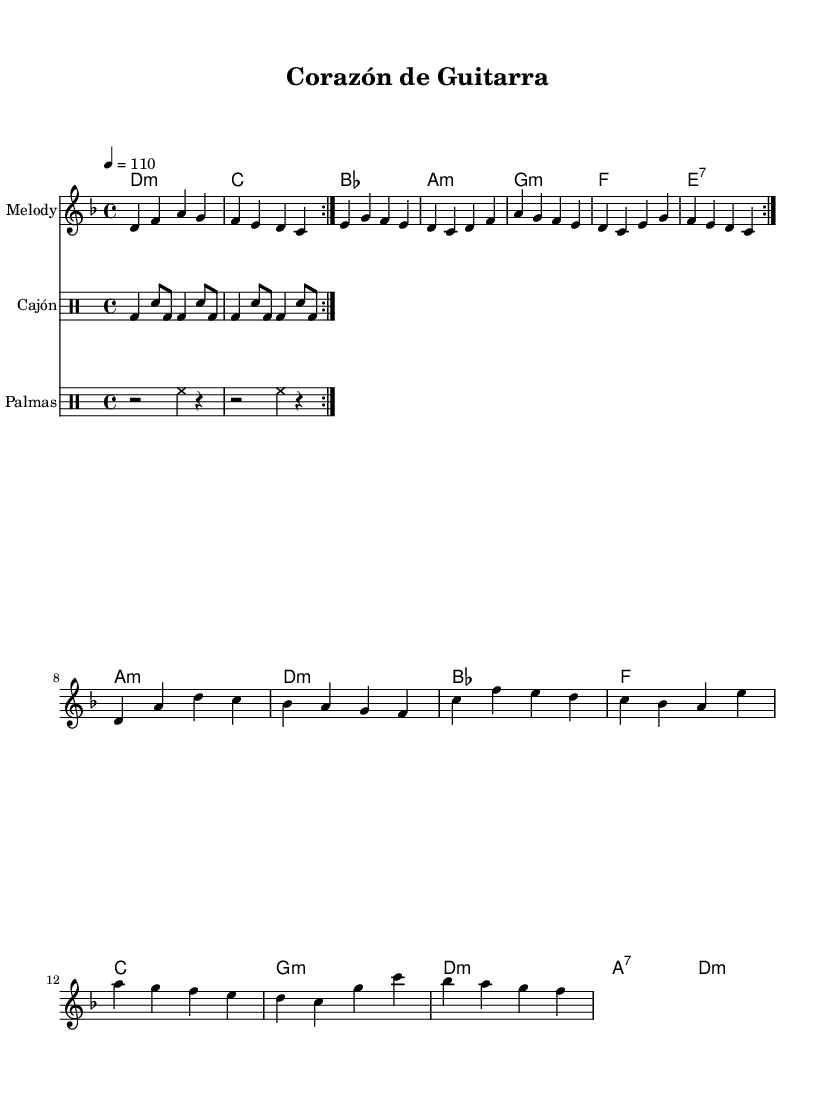What is the key signature of this music? The key is D minor, which has one flat (B flat). The key signature is indicated at the beginning of the staff.
Answer: D minor What is the time signature of this music? The time signature is indicated at the beginning of the piece, showing four beats per measure. It is represented as 4/4 at the beginning of the score.
Answer: 4/4 What is the tempo marking for this piece? The tempo is indicated at the beginning with "4 = 110," which represents a quarter note beat at a speed of 110 beats per minute.
Answer: 110 How many measures are in the melody section? By counting the measures in the melody line, we tally a total of 16 measures as indicated by the bar lines that separate each measure.
Answer: 16 What are the main instruments used in this piece? The score includes a melody staff, a cajón (drum), and palmas (hand clapping), specified in the instrument names at the start of each section.
Answer: Melody, Cajón, Palmas What is the first chord of the harmonies? The first chord indicated in the chord section is D minor, which is represented by the chord naming at the beginning of the harmonies.
Answer: D:m What is the rhythmic pattern of the cajón part? The cajón part consists of a repeating pattern throughout the piece, structured with a mixture of bass drum and snare beats, defined in the rhythmic notation.
Answer: BD, SN 